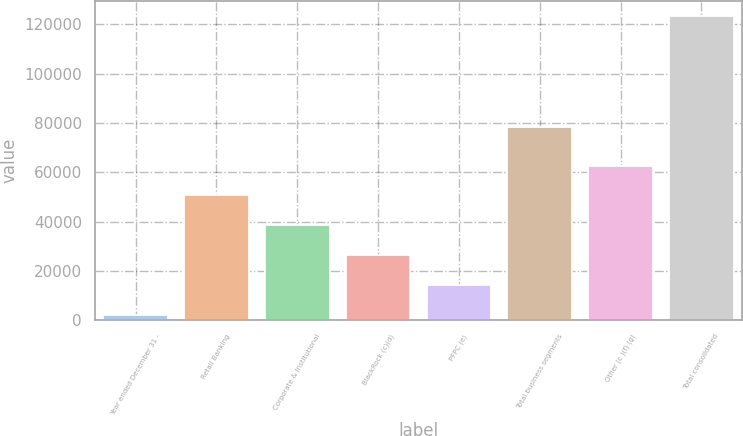Convert chart to OTSL. <chart><loc_0><loc_0><loc_500><loc_500><bar_chart><fcel>Year ended December 31 -<fcel>Retail Banking<fcel>Corporate & Institutional<fcel>BlackRock (c)(d)<fcel>PFPC (e)<fcel>Total business segments<fcel>Other (c )(f) (g)<fcel>Total consolidated<nl><fcel>2007<fcel>50571.4<fcel>38430.3<fcel>26289.2<fcel>14148.1<fcel>78211<fcel>62712.5<fcel>123418<nl></chart> 